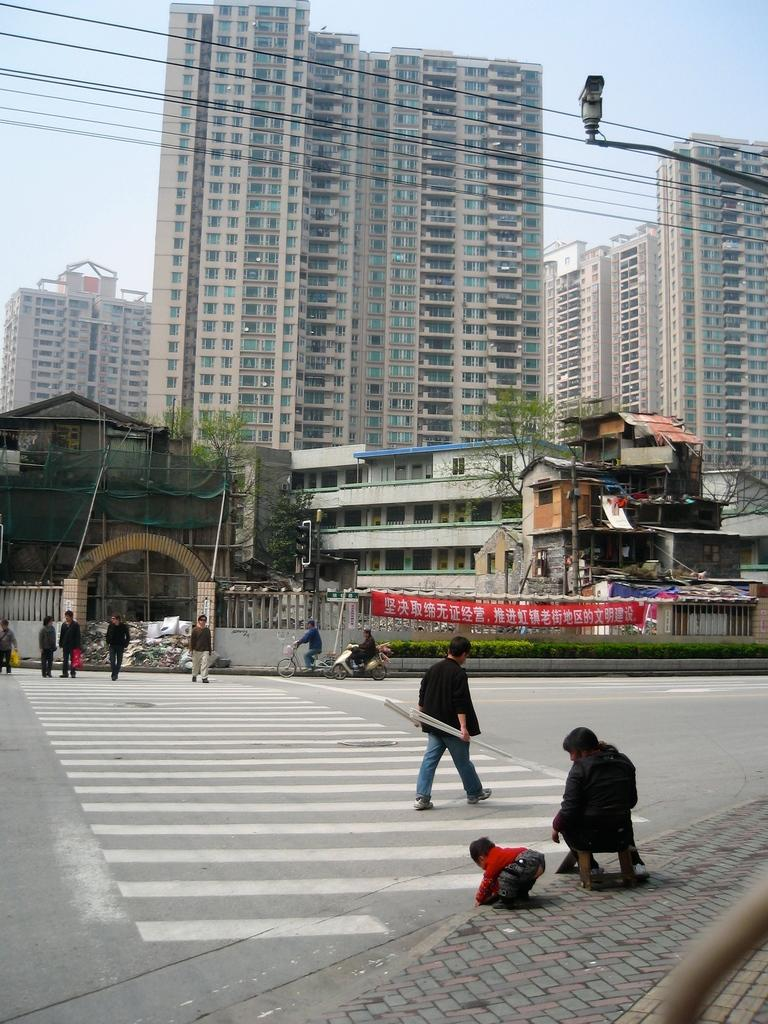Who or what can be seen in the image? There are people in the image. What type of natural elements are present in the image? There are trees in the image. What type of man-made structures are present in the image? There are buildings in the image. What type of infrastructure can be seen in the image? There are wires in the image. What type of lighting is present in the image? There is a street lamp in the image. What part of the natural environment is visible in the image? The sky is visible in the image. Can you tell me how many actors are performing on the branch in the image? There is no branch or actors present in the image. What type of downtown area is depicted in the image? The image does not depict a downtown area; it features people, trees, buildings, wires, a street lamp, and the sky. 